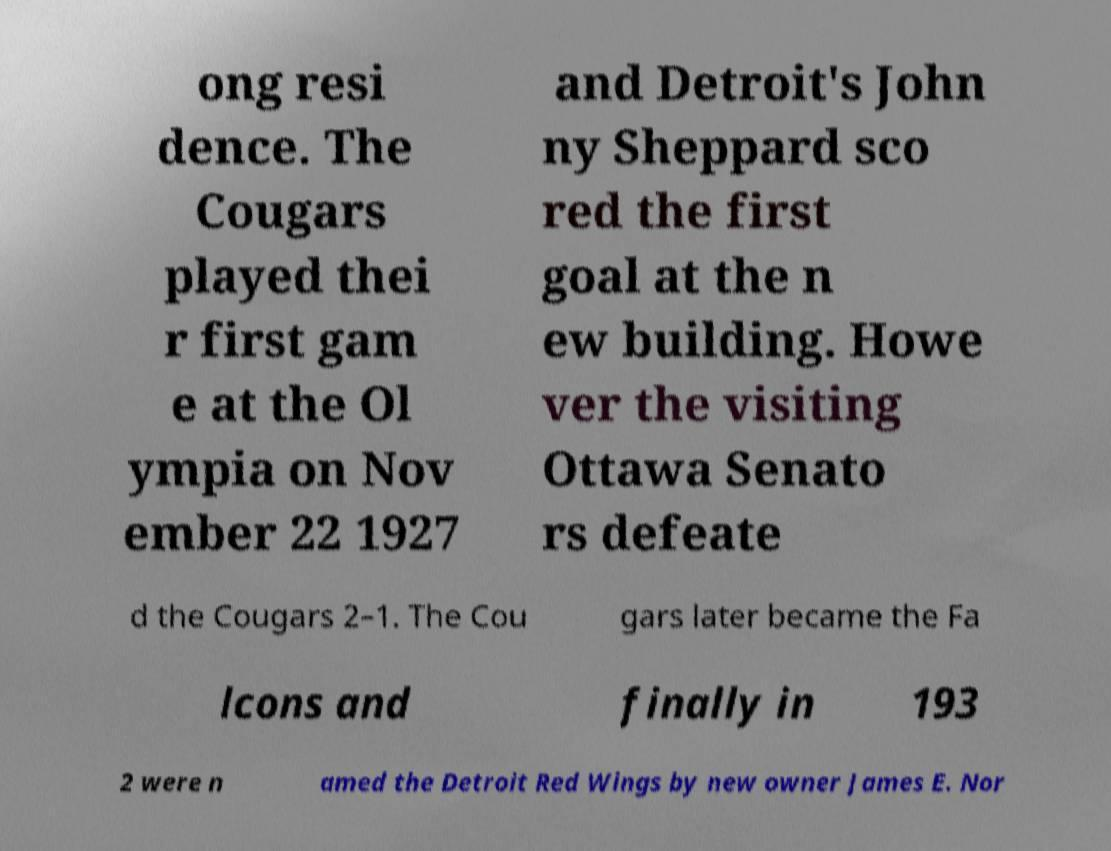I need the written content from this picture converted into text. Can you do that? ong resi dence. The Cougars played thei r first gam e at the Ol ympia on Nov ember 22 1927 and Detroit's John ny Sheppard sco red the first goal at the n ew building. Howe ver the visiting Ottawa Senato rs defeate d the Cougars 2–1. The Cou gars later became the Fa lcons and finally in 193 2 were n amed the Detroit Red Wings by new owner James E. Nor 